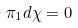<formula> <loc_0><loc_0><loc_500><loc_500>\pi _ { 1 } d \chi = 0</formula> 